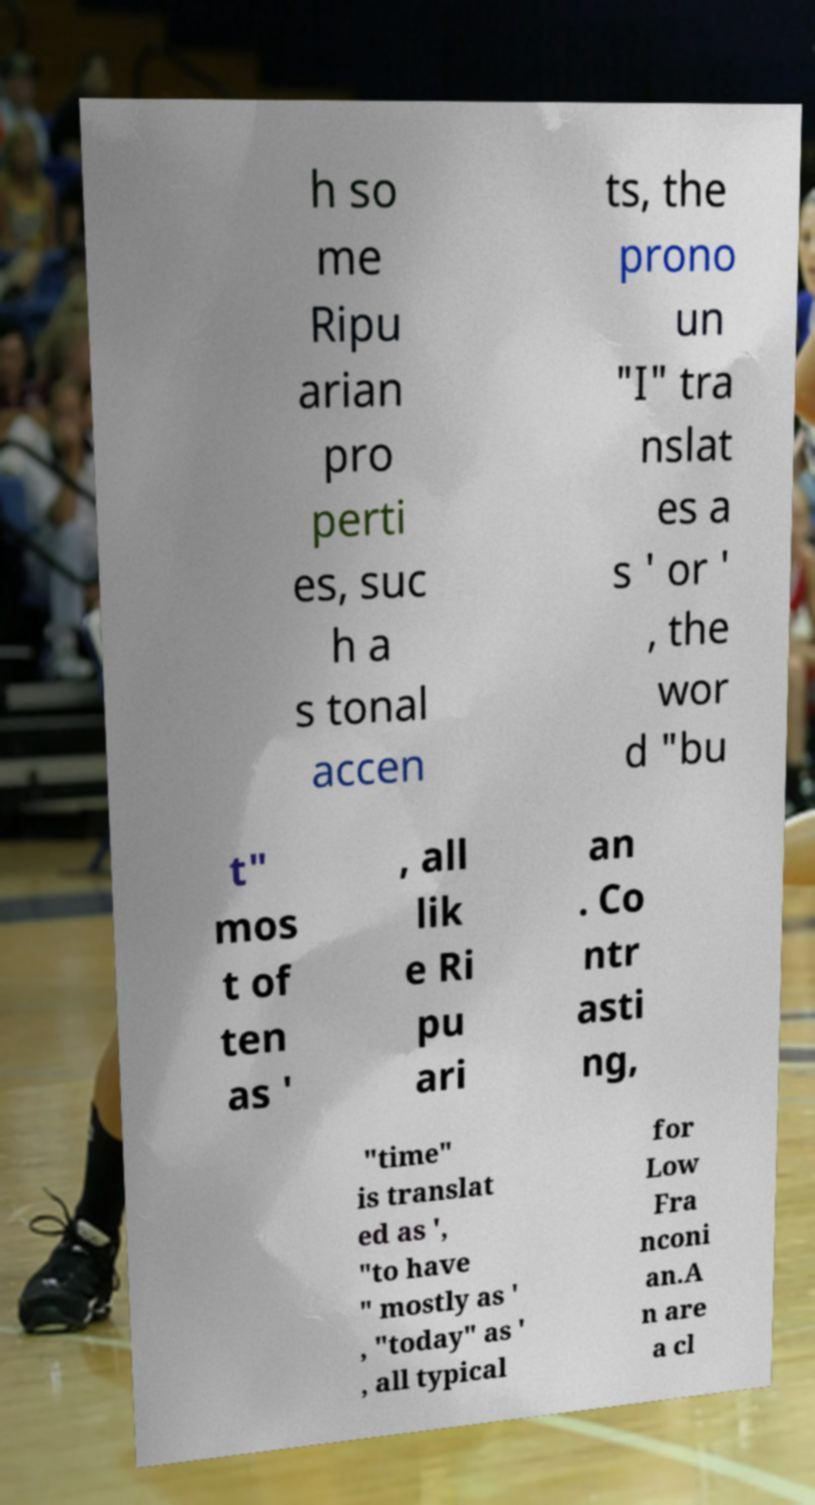Could you extract and type out the text from this image? h so me Ripu arian pro perti es, suc h a s tonal accen ts, the prono un "I" tra nslat es a s ' or ' , the wor d "bu t" mos t of ten as ' , all lik e Ri pu ari an . Co ntr asti ng, "time" is translat ed as ', "to have " mostly as ' , "today" as ' , all typical for Low Fra nconi an.A n are a cl 